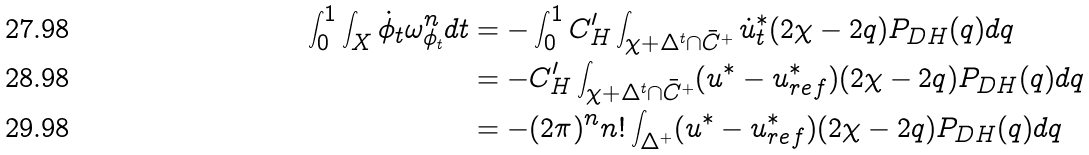<formula> <loc_0><loc_0><loc_500><loc_500>\int _ { 0 } ^ { 1 } \int _ { X } \dot { \phi } _ { t } \omega _ { \phi _ { t } } ^ { n } d t & = - \int _ { 0 } ^ { 1 } C _ { H } ^ { \prime } \int _ { \chi + \Delta ^ { t } \cap \bar { C } ^ { + } } \dot { u } _ { t } ^ { * } ( 2 \chi - 2 q ) P _ { D H } ( q ) d q \\ & = - C _ { H } ^ { \prime } \int _ { \chi + \Delta ^ { t } \cap \bar { C } ^ { + } } ( u ^ { * } - u _ { r e f } ^ { * } ) ( 2 \chi - 2 q ) P _ { D H } ( q ) d q \\ & = - ( 2 \pi ) ^ { n } n ! \int _ { \Delta ^ { + } } ( u ^ { * } - u _ { r e f } ^ { * } ) ( 2 \chi - 2 q ) P _ { D H } ( q ) d q</formula> 